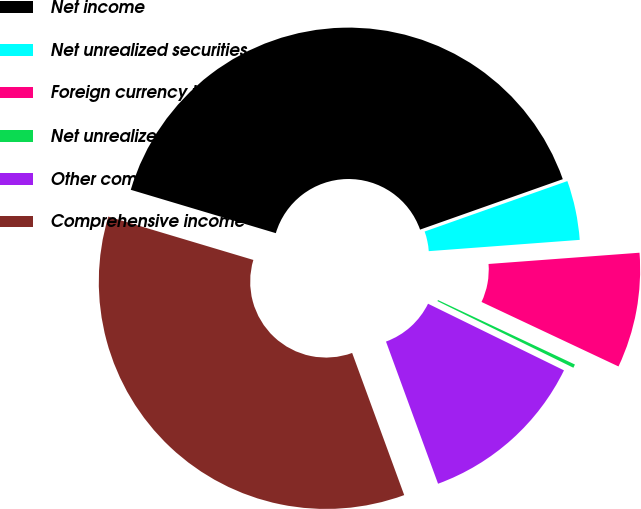<chart> <loc_0><loc_0><loc_500><loc_500><pie_chart><fcel>Net income<fcel>Net unrealized securities<fcel>Foreign currency translation<fcel>Net unrealized pension and<fcel>Other comprehensive income<fcel>Comprehensive income<nl><fcel>39.97%<fcel>4.22%<fcel>8.19%<fcel>0.25%<fcel>12.16%<fcel>35.21%<nl></chart> 